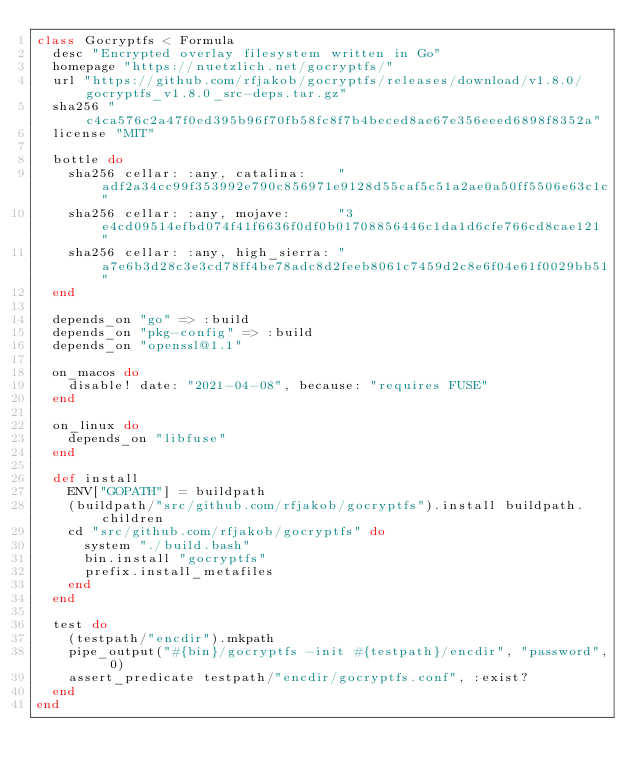Convert code to text. <code><loc_0><loc_0><loc_500><loc_500><_Ruby_>class Gocryptfs < Formula
  desc "Encrypted overlay filesystem written in Go"
  homepage "https://nuetzlich.net/gocryptfs/"
  url "https://github.com/rfjakob/gocryptfs/releases/download/v1.8.0/gocryptfs_v1.8.0_src-deps.tar.gz"
  sha256 "c4ca576c2a47f0ed395b96f70fb58fc8f7b4beced8ae67e356eeed6898f8352a"
  license "MIT"

  bottle do
    sha256 cellar: :any, catalina:    "adf2a34cc99f353992e790c856971e9128d55caf5c51a2ae0a50ff5506e63c1c"
    sha256 cellar: :any, mojave:      "3e4cd09514efbd074f41f6636f0df0b01708856446c1da1d6cfe766cd8cae121"
    sha256 cellar: :any, high_sierra: "a7e6b3d28c3e3cd78ff4be78adc8d2feeb8061c7459d2c8e6f04e61f0029bb51"
  end

  depends_on "go" => :build
  depends_on "pkg-config" => :build
  depends_on "openssl@1.1"

  on_macos do
    disable! date: "2021-04-08", because: "requires FUSE"
  end

  on_linux do
    depends_on "libfuse"
  end

  def install
    ENV["GOPATH"] = buildpath
    (buildpath/"src/github.com/rfjakob/gocryptfs").install buildpath.children
    cd "src/github.com/rfjakob/gocryptfs" do
      system "./build.bash"
      bin.install "gocryptfs"
      prefix.install_metafiles
    end
  end

  test do
    (testpath/"encdir").mkpath
    pipe_output("#{bin}/gocryptfs -init #{testpath}/encdir", "password", 0)
    assert_predicate testpath/"encdir/gocryptfs.conf", :exist?
  end
end
</code> 